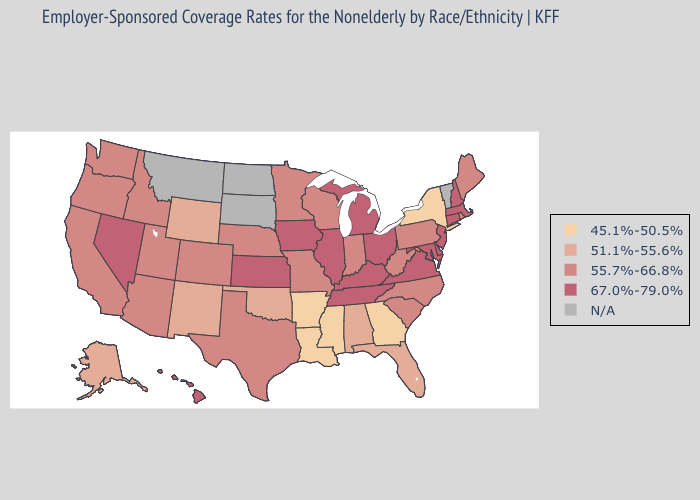What is the lowest value in the South?
Concise answer only. 45.1%-50.5%. Name the states that have a value in the range 67.0%-79.0%?
Write a very short answer. Connecticut, Delaware, Hawaii, Illinois, Iowa, Kansas, Kentucky, Maryland, Massachusetts, Michigan, Nevada, New Hampshire, New Jersey, Ohio, Tennessee, Virginia. Does Missouri have the highest value in the MidWest?
Quick response, please. No. What is the lowest value in the Northeast?
Write a very short answer. 45.1%-50.5%. What is the lowest value in the South?
Keep it brief. 45.1%-50.5%. Is the legend a continuous bar?
Keep it brief. No. Name the states that have a value in the range 51.1%-55.6%?
Give a very brief answer. Alabama, Alaska, Florida, New Mexico, Oklahoma, Wyoming. Does the first symbol in the legend represent the smallest category?
Be succinct. Yes. What is the value of Arizona?
Quick response, please. 55.7%-66.8%. Does the map have missing data?
Give a very brief answer. Yes. What is the highest value in states that border Arkansas?
Answer briefly. 67.0%-79.0%. Which states have the lowest value in the West?
Give a very brief answer. Alaska, New Mexico, Wyoming. 